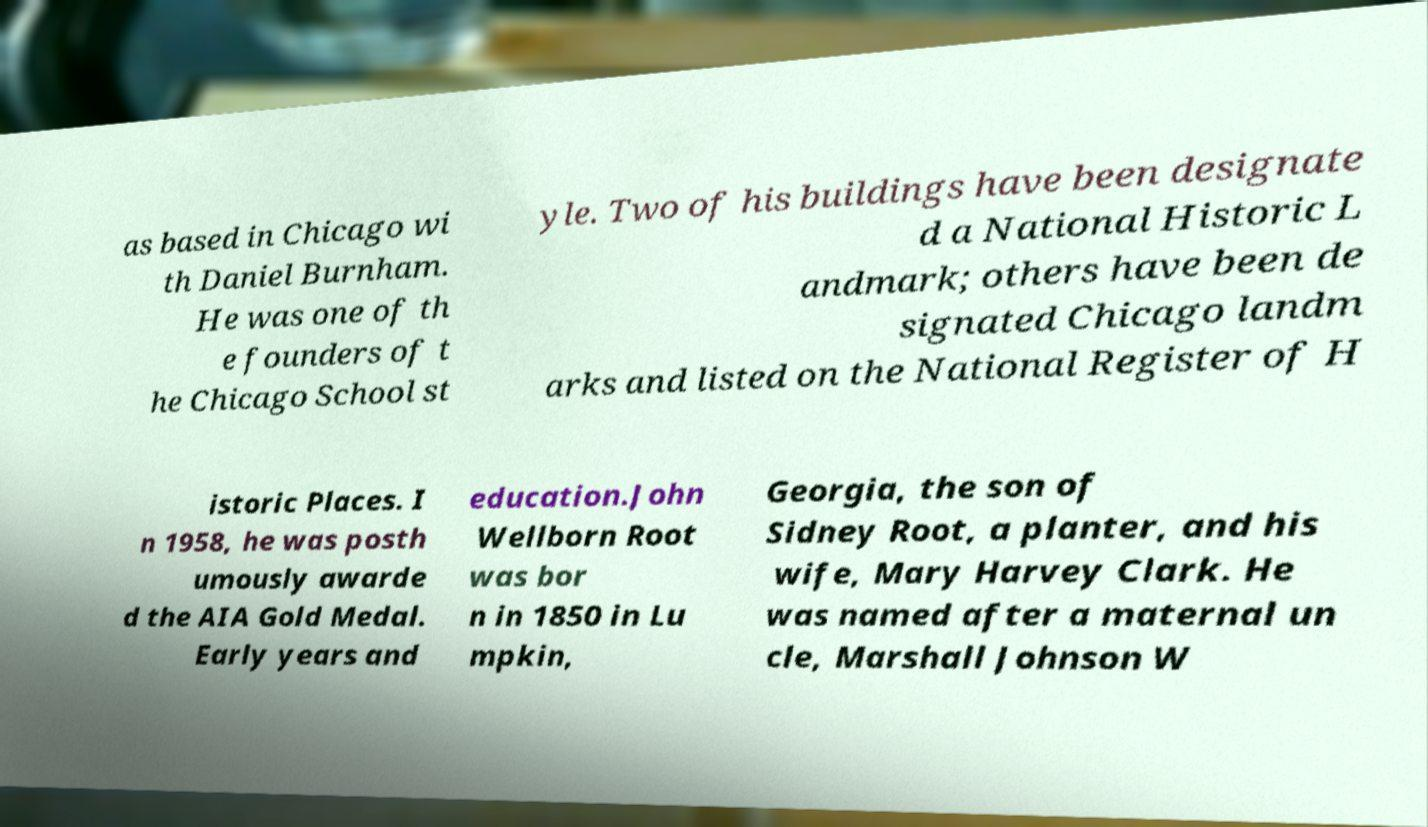What messages or text are displayed in this image? I need them in a readable, typed format. as based in Chicago wi th Daniel Burnham. He was one of th e founders of t he Chicago School st yle. Two of his buildings have been designate d a National Historic L andmark; others have been de signated Chicago landm arks and listed on the National Register of H istoric Places. I n 1958, he was posth umously awarde d the AIA Gold Medal. Early years and education.John Wellborn Root was bor n in 1850 in Lu mpkin, Georgia, the son of Sidney Root, a planter, and his wife, Mary Harvey Clark. He was named after a maternal un cle, Marshall Johnson W 